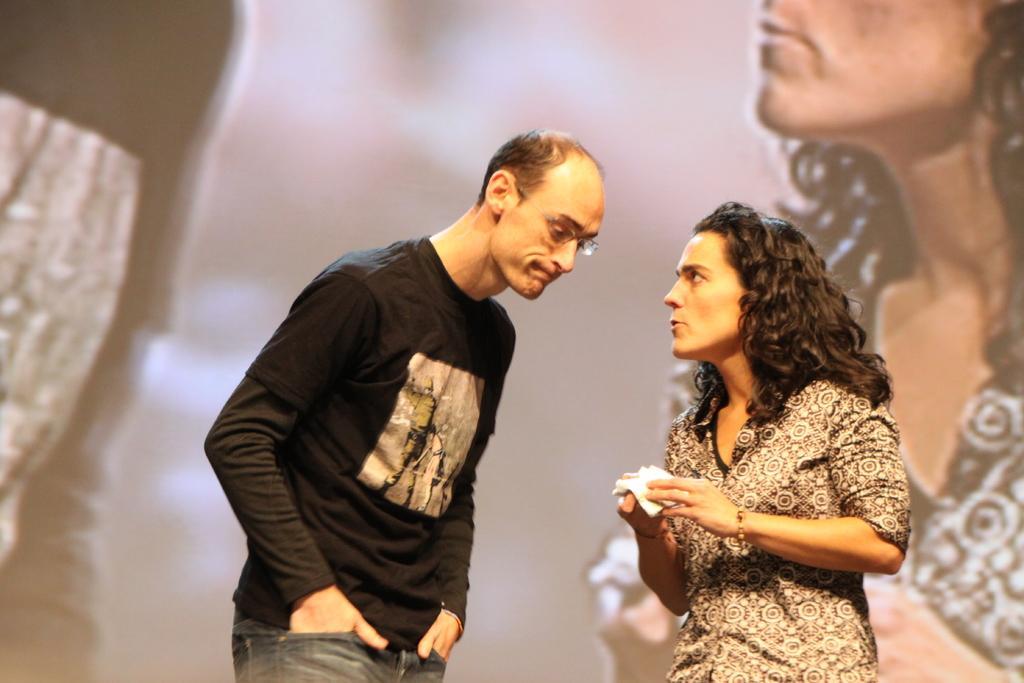Could you give a brief overview of what you see in this image? In the middle a man is standing, he wore black color t-shirt and jeans. On the right side a woman is standing and speaking, she wore shirt. 